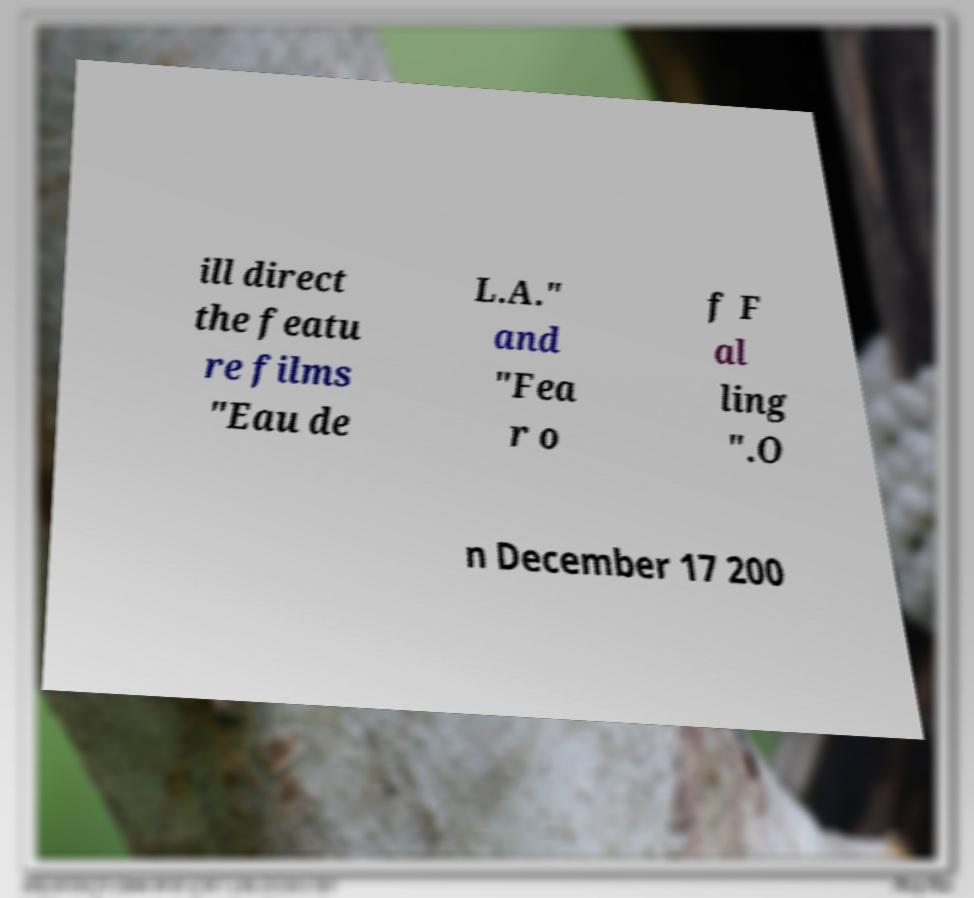Please read and relay the text visible in this image. What does it say? ill direct the featu re films "Eau de L.A." and "Fea r o f F al ling ".O n December 17 200 